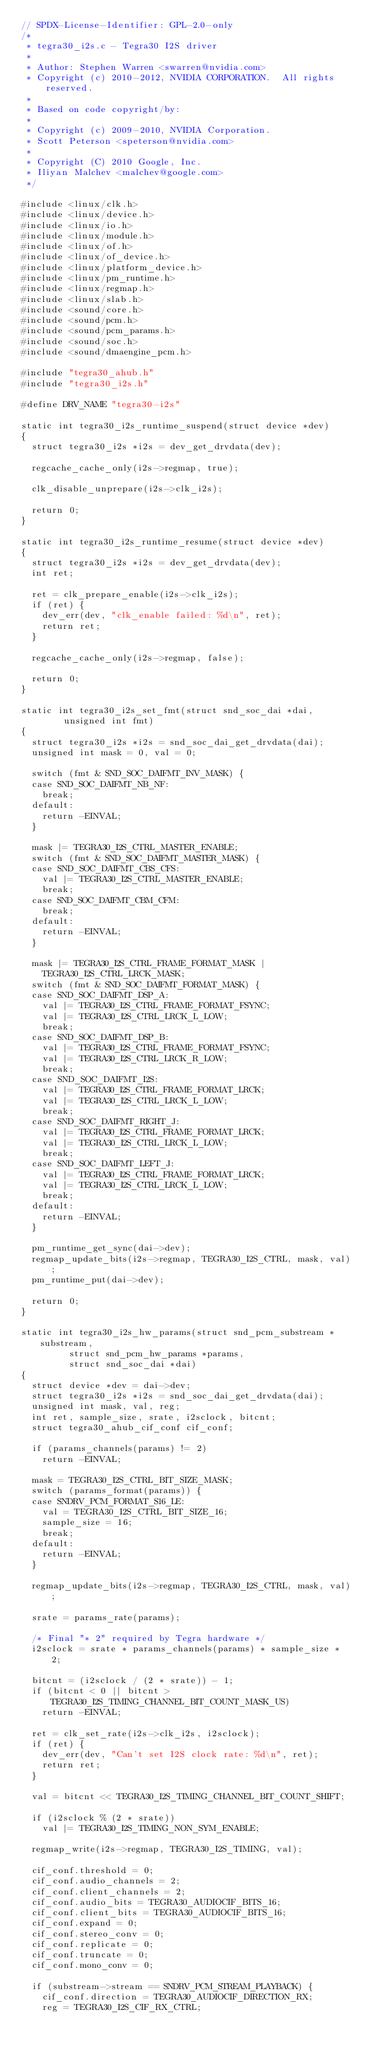Convert code to text. <code><loc_0><loc_0><loc_500><loc_500><_C_>// SPDX-License-Identifier: GPL-2.0-only
/*
 * tegra30_i2s.c - Tegra30 I2S driver
 *
 * Author: Stephen Warren <swarren@nvidia.com>
 * Copyright (c) 2010-2012, NVIDIA CORPORATION.  All rights reserved.
 *
 * Based on code copyright/by:
 *
 * Copyright (c) 2009-2010, NVIDIA Corporation.
 * Scott Peterson <speterson@nvidia.com>
 *
 * Copyright (C) 2010 Google, Inc.
 * Iliyan Malchev <malchev@google.com>
 */

#include <linux/clk.h>
#include <linux/device.h>
#include <linux/io.h>
#include <linux/module.h>
#include <linux/of.h>
#include <linux/of_device.h>
#include <linux/platform_device.h>
#include <linux/pm_runtime.h>
#include <linux/regmap.h>
#include <linux/slab.h>
#include <sound/core.h>
#include <sound/pcm.h>
#include <sound/pcm_params.h>
#include <sound/soc.h>
#include <sound/dmaengine_pcm.h>

#include "tegra30_ahub.h"
#include "tegra30_i2s.h"

#define DRV_NAME "tegra30-i2s"

static int tegra30_i2s_runtime_suspend(struct device *dev)
{
	struct tegra30_i2s *i2s = dev_get_drvdata(dev);

	regcache_cache_only(i2s->regmap, true);

	clk_disable_unprepare(i2s->clk_i2s);

	return 0;
}

static int tegra30_i2s_runtime_resume(struct device *dev)
{
	struct tegra30_i2s *i2s = dev_get_drvdata(dev);
	int ret;

	ret = clk_prepare_enable(i2s->clk_i2s);
	if (ret) {
		dev_err(dev, "clk_enable failed: %d\n", ret);
		return ret;
	}

	regcache_cache_only(i2s->regmap, false);

	return 0;
}

static int tegra30_i2s_set_fmt(struct snd_soc_dai *dai,
				unsigned int fmt)
{
	struct tegra30_i2s *i2s = snd_soc_dai_get_drvdata(dai);
	unsigned int mask = 0, val = 0;

	switch (fmt & SND_SOC_DAIFMT_INV_MASK) {
	case SND_SOC_DAIFMT_NB_NF:
		break;
	default:
		return -EINVAL;
	}

	mask |= TEGRA30_I2S_CTRL_MASTER_ENABLE;
	switch (fmt & SND_SOC_DAIFMT_MASTER_MASK) {
	case SND_SOC_DAIFMT_CBS_CFS:
		val |= TEGRA30_I2S_CTRL_MASTER_ENABLE;
		break;
	case SND_SOC_DAIFMT_CBM_CFM:
		break;
	default:
		return -EINVAL;
	}

	mask |= TEGRA30_I2S_CTRL_FRAME_FORMAT_MASK |
		TEGRA30_I2S_CTRL_LRCK_MASK;
	switch (fmt & SND_SOC_DAIFMT_FORMAT_MASK) {
	case SND_SOC_DAIFMT_DSP_A:
		val |= TEGRA30_I2S_CTRL_FRAME_FORMAT_FSYNC;
		val |= TEGRA30_I2S_CTRL_LRCK_L_LOW;
		break;
	case SND_SOC_DAIFMT_DSP_B:
		val |= TEGRA30_I2S_CTRL_FRAME_FORMAT_FSYNC;
		val |= TEGRA30_I2S_CTRL_LRCK_R_LOW;
		break;
	case SND_SOC_DAIFMT_I2S:
		val |= TEGRA30_I2S_CTRL_FRAME_FORMAT_LRCK;
		val |= TEGRA30_I2S_CTRL_LRCK_L_LOW;
		break;
	case SND_SOC_DAIFMT_RIGHT_J:
		val |= TEGRA30_I2S_CTRL_FRAME_FORMAT_LRCK;
		val |= TEGRA30_I2S_CTRL_LRCK_L_LOW;
		break;
	case SND_SOC_DAIFMT_LEFT_J:
		val |= TEGRA30_I2S_CTRL_FRAME_FORMAT_LRCK;
		val |= TEGRA30_I2S_CTRL_LRCK_L_LOW;
		break;
	default:
		return -EINVAL;
	}

	pm_runtime_get_sync(dai->dev);
	regmap_update_bits(i2s->regmap, TEGRA30_I2S_CTRL, mask, val);
	pm_runtime_put(dai->dev);

	return 0;
}

static int tegra30_i2s_hw_params(struct snd_pcm_substream *substream,
				 struct snd_pcm_hw_params *params,
				 struct snd_soc_dai *dai)
{
	struct device *dev = dai->dev;
	struct tegra30_i2s *i2s = snd_soc_dai_get_drvdata(dai);
	unsigned int mask, val, reg;
	int ret, sample_size, srate, i2sclock, bitcnt;
	struct tegra30_ahub_cif_conf cif_conf;

	if (params_channels(params) != 2)
		return -EINVAL;

	mask = TEGRA30_I2S_CTRL_BIT_SIZE_MASK;
	switch (params_format(params)) {
	case SNDRV_PCM_FORMAT_S16_LE:
		val = TEGRA30_I2S_CTRL_BIT_SIZE_16;
		sample_size = 16;
		break;
	default:
		return -EINVAL;
	}

	regmap_update_bits(i2s->regmap, TEGRA30_I2S_CTRL, mask, val);

	srate = params_rate(params);

	/* Final "* 2" required by Tegra hardware */
	i2sclock = srate * params_channels(params) * sample_size * 2;

	bitcnt = (i2sclock / (2 * srate)) - 1;
	if (bitcnt < 0 || bitcnt > TEGRA30_I2S_TIMING_CHANNEL_BIT_COUNT_MASK_US)
		return -EINVAL;

	ret = clk_set_rate(i2s->clk_i2s, i2sclock);
	if (ret) {
		dev_err(dev, "Can't set I2S clock rate: %d\n", ret);
		return ret;
	}

	val = bitcnt << TEGRA30_I2S_TIMING_CHANNEL_BIT_COUNT_SHIFT;

	if (i2sclock % (2 * srate))
		val |= TEGRA30_I2S_TIMING_NON_SYM_ENABLE;

	regmap_write(i2s->regmap, TEGRA30_I2S_TIMING, val);

	cif_conf.threshold = 0;
	cif_conf.audio_channels = 2;
	cif_conf.client_channels = 2;
	cif_conf.audio_bits = TEGRA30_AUDIOCIF_BITS_16;
	cif_conf.client_bits = TEGRA30_AUDIOCIF_BITS_16;
	cif_conf.expand = 0;
	cif_conf.stereo_conv = 0;
	cif_conf.replicate = 0;
	cif_conf.truncate = 0;
	cif_conf.mono_conv = 0;

	if (substream->stream == SNDRV_PCM_STREAM_PLAYBACK) {
		cif_conf.direction = TEGRA30_AUDIOCIF_DIRECTION_RX;
		reg = TEGRA30_I2S_CIF_RX_CTRL;</code> 